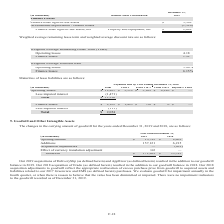From Zix Corporation's financial document, Which companies did zix acquire in 2019 and 2018 respectively? The document shows two values: DeliverySlip (as defined herein) and AppRiver (as defined herein) and Erado. From the document: "Our 2019 acquisitions of DeliverySlip (as defined herein) and AppRiver (as defined herein) resulted in the addition to our goodwill balance in 2019. O..." Also, What were the organisations the company purchased in 2017? The document shows two values: Greenview and EMS. From the document: "quired assets and liabilities related to our 2017 Greenview and EMS (as defined herein) purchases. We evaluate goodwill for impairment annually in the..." Also, How much was the Opening balance for goodwill and other intangible assets in 2019 and 2018 respectively? The document shows two values: 13,783 and 8,469 (in thousands). From the document: "Opening balance $ 13,783 $ 8,469 Opening balance $ 13,783 $ 8,469..." Also, can you calculate: What is the percentage change in goodwill from 2018 to 2019? To answer this question, I need to perform calculations using the financial data. The calculation is: (171,209-13,783)/13,783, which equals 1142.18 (percentage). This is based on the information: "Goodwill $ 171,209 $ 13,783 Goodwill $ 171,209 $ 13,783..." The key data points involved are: 13,783, 171,209. Also, From 2018 to 2019, how many years was the Opening balance more than $5,000 thousand? Counting the relevant items in the document: 2018 ,  2019, I find 2 instances. The key data points involved are: 2018, 2019. Also, can you calculate: How much is the total additions and Acquisition adjustments over 2018 and 2019? Based on the calculation: 157,121+6,215-901, the result is 162435 (in thousands). This is based on the information: "Additions 157,121 6,215 Additions 157,121 6,215 Acquisition adjustments — (901 )..." The key data points involved are: 157,121, 6,215, 901. 